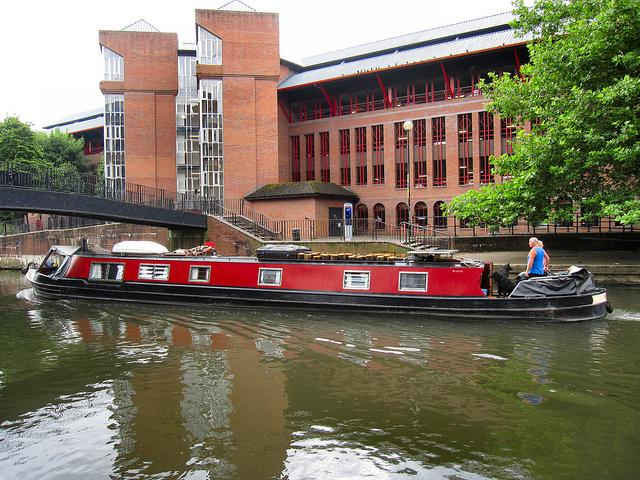How is this vessel being propelled? Please explain your reasoning. motor. There is a motor shown at the back of the boat. 